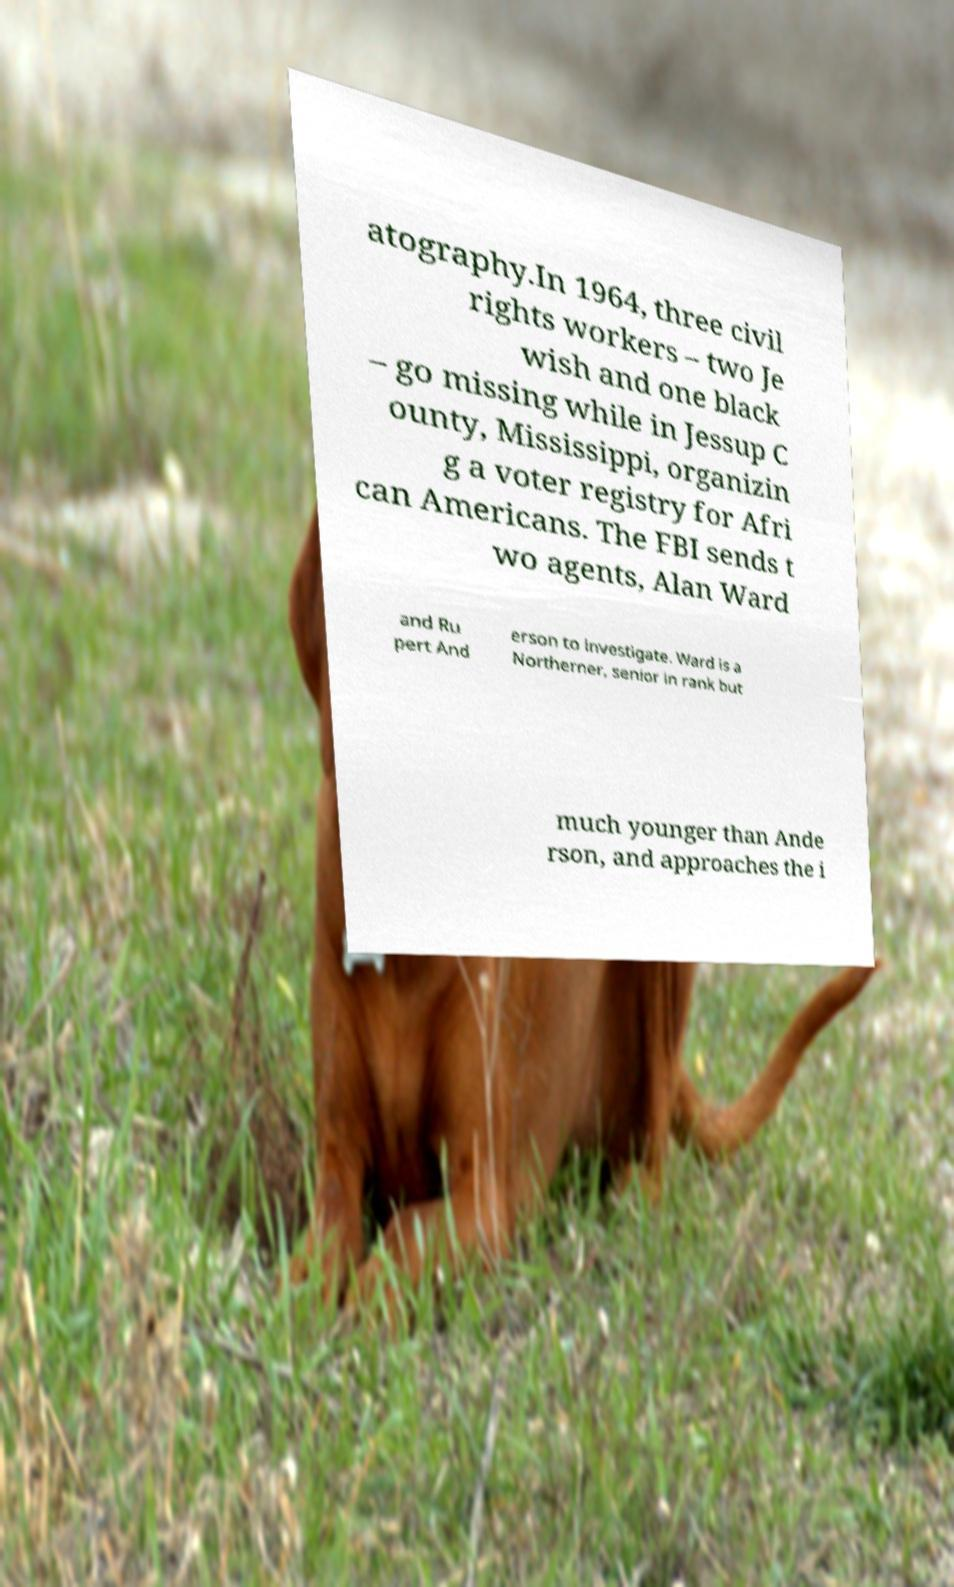Can you accurately transcribe the text from the provided image for me? atography.In 1964, three civil rights workers – two Je wish and one black – go missing while in Jessup C ounty, Mississippi, organizin g a voter registry for Afri can Americans. The FBI sends t wo agents, Alan Ward and Ru pert And erson to investigate. Ward is a Northerner, senior in rank but much younger than Ande rson, and approaches the i 